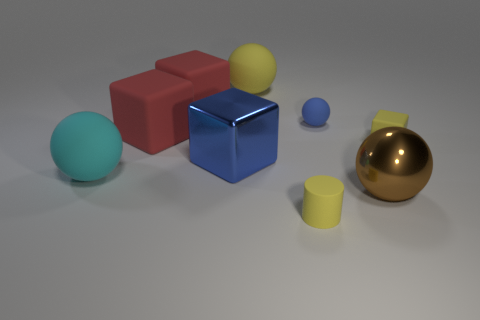What is the shape of the yellow object that is the same size as the brown metal ball?
Keep it short and to the point. Sphere. Are there any red cubes that are right of the big matte object that is to the right of the shiny block?
Your answer should be very brief. No. There is a big cyan thing that is the same shape as the big brown shiny object; what material is it?
Keep it short and to the point. Rubber. Is the number of large rubber cylinders greater than the number of large blue things?
Your response must be concise. No. Do the metal cube and the large matte sphere in front of the large blue object have the same color?
Your answer should be compact. No. The small thing that is behind the large brown metallic object and left of the brown metal object is what color?
Your answer should be very brief. Blue. What number of other things are there of the same material as the small cube
Make the answer very short. 6. Are there fewer large yellow rubber balls than big brown metal cylinders?
Offer a terse response. No. Is the material of the large yellow thing the same as the blue object that is on the right side of the blue metallic block?
Your answer should be very brief. Yes. What shape is the blue thing right of the small cylinder?
Your answer should be compact. Sphere. 